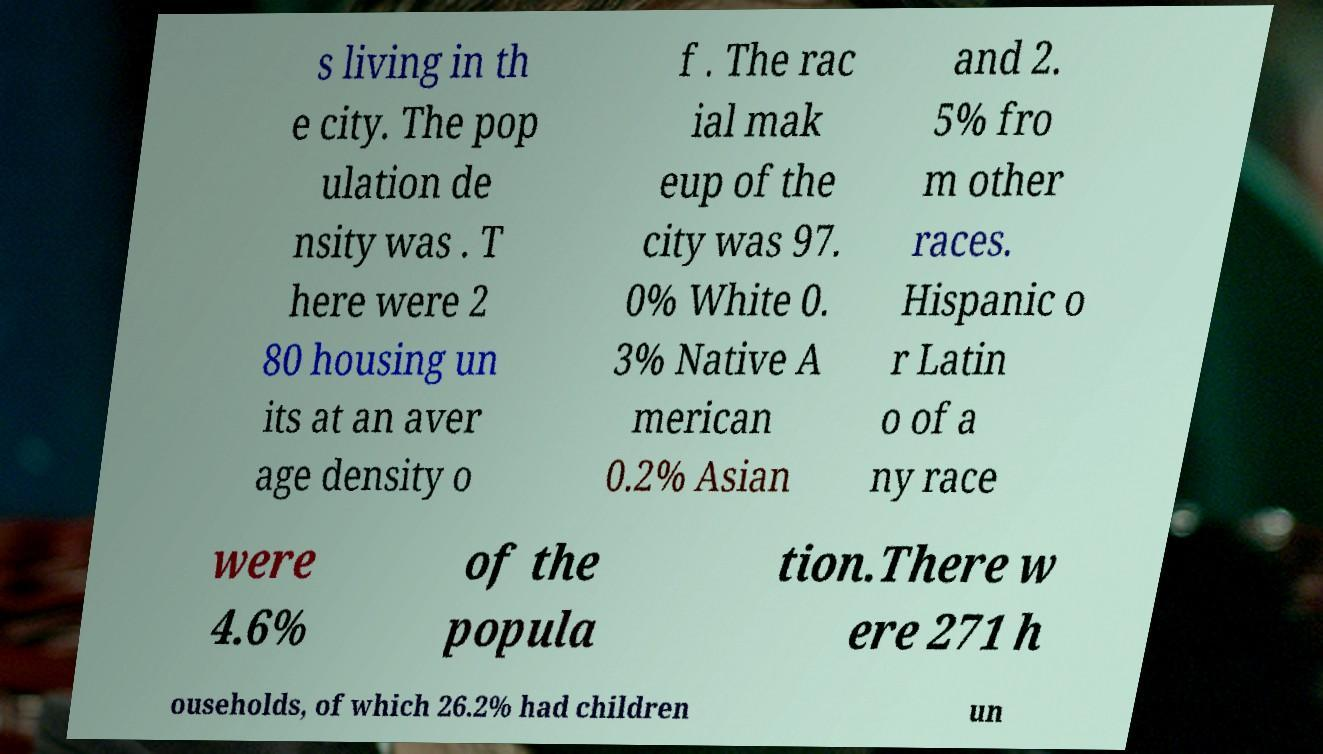What messages or text are displayed in this image? I need them in a readable, typed format. s living in th e city. The pop ulation de nsity was . T here were 2 80 housing un its at an aver age density o f . The rac ial mak eup of the city was 97. 0% White 0. 3% Native A merican 0.2% Asian and 2. 5% fro m other races. Hispanic o r Latin o of a ny race were 4.6% of the popula tion.There w ere 271 h ouseholds, of which 26.2% had children un 